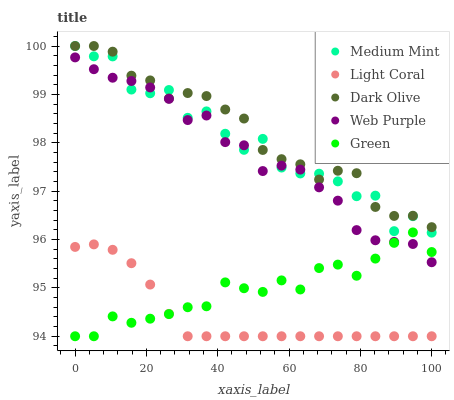Does Light Coral have the minimum area under the curve?
Answer yes or no. Yes. Does Dark Olive have the maximum area under the curve?
Answer yes or no. Yes. Does Web Purple have the minimum area under the curve?
Answer yes or no. No. Does Web Purple have the maximum area under the curve?
Answer yes or no. No. Is Light Coral the smoothest?
Answer yes or no. Yes. Is Medium Mint the roughest?
Answer yes or no. Yes. Is Web Purple the smoothest?
Answer yes or no. No. Is Web Purple the roughest?
Answer yes or no. No. Does Light Coral have the lowest value?
Answer yes or no. Yes. Does Web Purple have the lowest value?
Answer yes or no. No. Does Dark Olive have the highest value?
Answer yes or no. Yes. Does Web Purple have the highest value?
Answer yes or no. No. Is Web Purple less than Dark Olive?
Answer yes or no. Yes. Is Medium Mint greater than Green?
Answer yes or no. Yes. Does Green intersect Web Purple?
Answer yes or no. Yes. Is Green less than Web Purple?
Answer yes or no. No. Is Green greater than Web Purple?
Answer yes or no. No. Does Web Purple intersect Dark Olive?
Answer yes or no. No. 